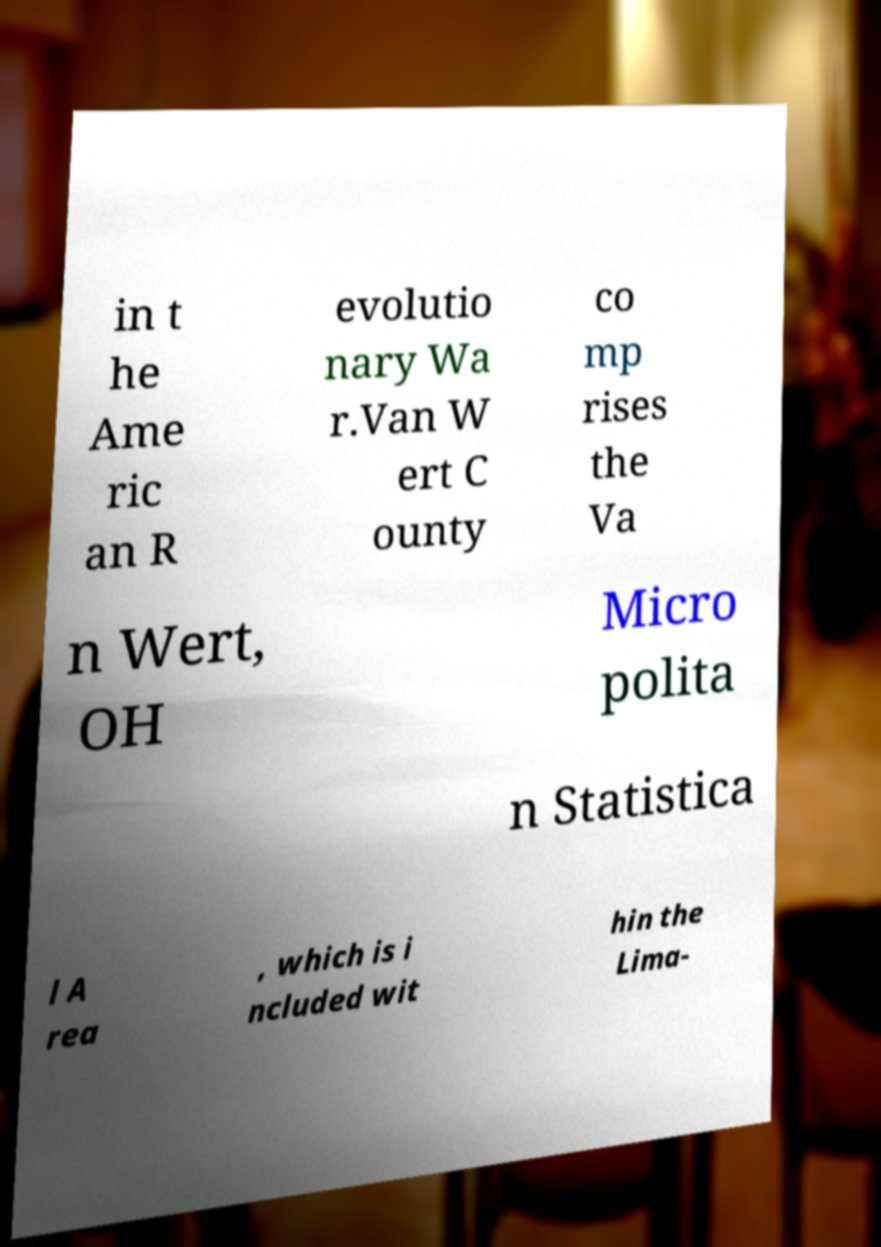Could you assist in decoding the text presented in this image and type it out clearly? in t he Ame ric an R evolutio nary Wa r.Van W ert C ounty co mp rises the Va n Wert, OH Micro polita n Statistica l A rea , which is i ncluded wit hin the Lima- 